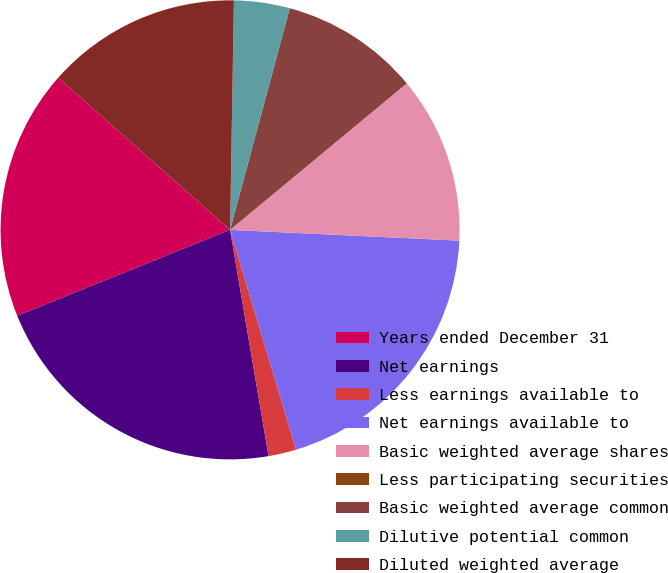Convert chart. <chart><loc_0><loc_0><loc_500><loc_500><pie_chart><fcel>Years ended December 31<fcel>Net earnings<fcel>Less earnings available to<fcel>Net earnings available to<fcel>Basic weighted average shares<fcel>Less participating securities<fcel>Basic weighted average common<fcel>Dilutive potential common<fcel>Diluted weighted average<nl><fcel>17.65%<fcel>21.57%<fcel>1.96%<fcel>19.61%<fcel>11.76%<fcel>0.0%<fcel>9.8%<fcel>3.92%<fcel>13.73%<nl></chart> 